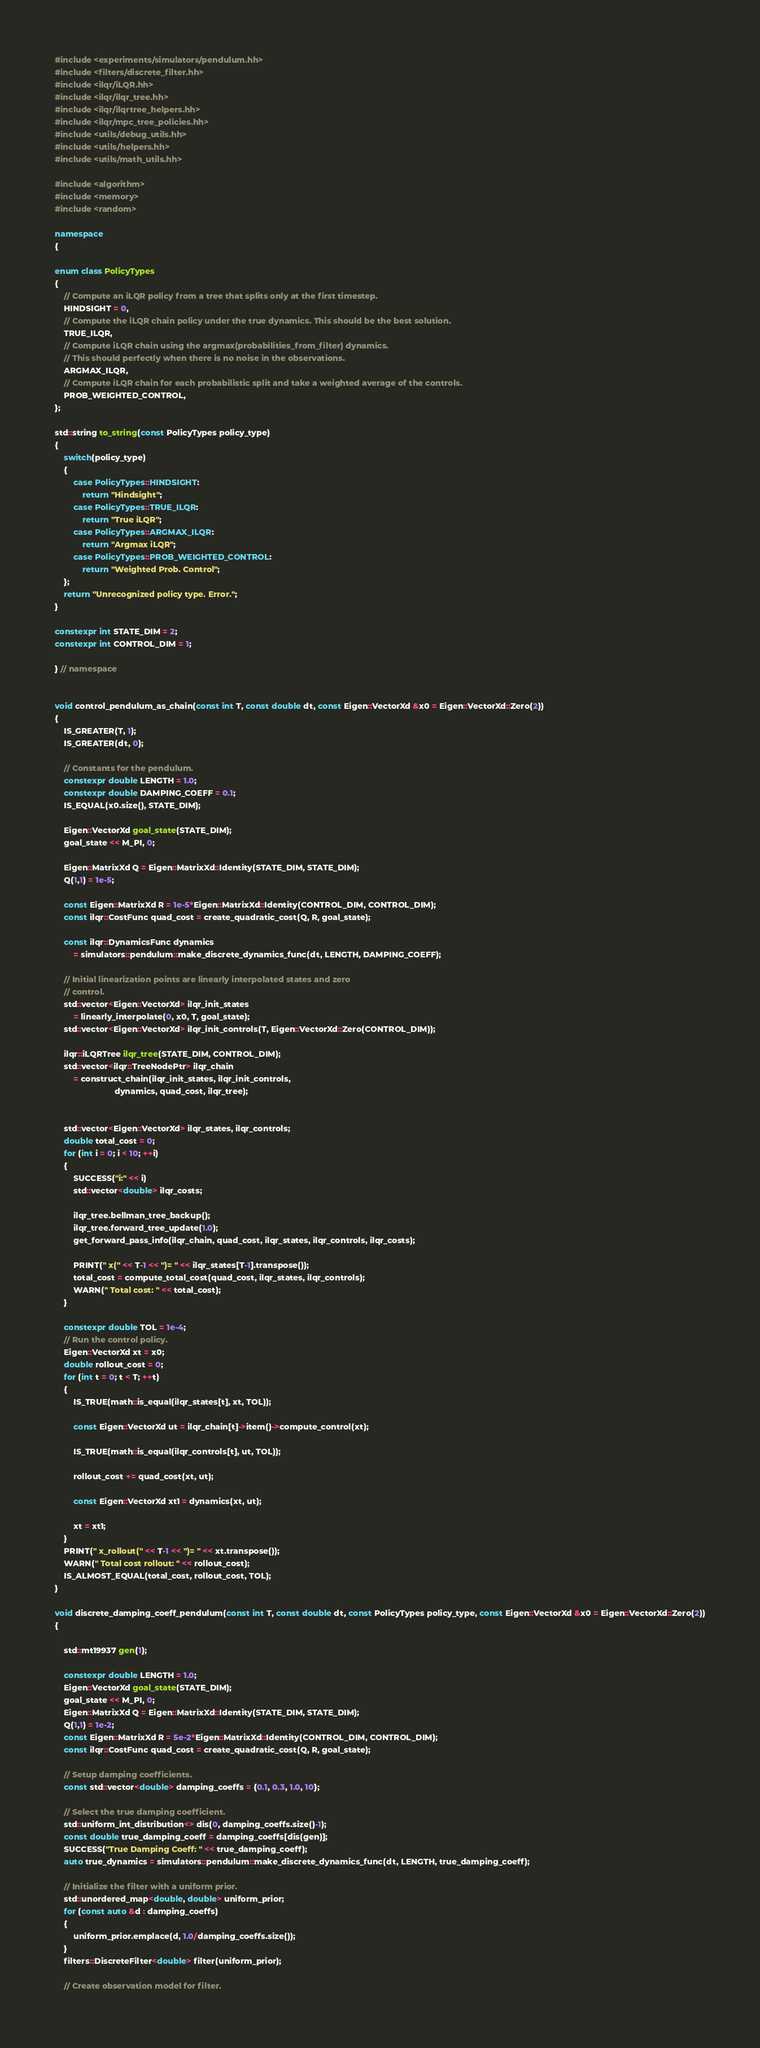Convert code to text. <code><loc_0><loc_0><loc_500><loc_500><_C++_>
#include <experiments/simulators/pendulum.hh>
#include <filters/discrete_filter.hh>
#include <ilqr/iLQR.hh>
#include <ilqr/ilqr_tree.hh>
#include <ilqr/ilqrtree_helpers.hh>
#include <ilqr/mpc_tree_policies.hh>
#include <utils/debug_utils.hh>
#include <utils/helpers.hh>
#include <utils/math_utils.hh>

#include <algorithm>
#include <memory>
#include <random>

namespace 
{

enum class PolicyTypes
{
    // Compute an iLQR policy from a tree that splits only at the first timestep.
    HINDSIGHT = 0,
    // Compute the iLQR chain policy under the true dynamics. This should be the best solution.
    TRUE_ILQR,
    // Compute iLQR chain using the argmax(probabilities_from_filter) dynamics.
    // This should perfectly when there is no noise in the observations.
    ARGMAX_ILQR,
    // Compute iLQR chain for each probabilistic split and take a weighted average of the controls.
    PROB_WEIGHTED_CONTROL,
};

std::string to_string(const PolicyTypes policy_type)
{
    switch(policy_type)
    {
        case PolicyTypes::HINDSIGHT:
            return "Hindsight";
        case PolicyTypes::TRUE_ILQR:
            return "True iLQR";
        case PolicyTypes::ARGMAX_ILQR:
            return "Argmax iLQR";
        case PolicyTypes::PROB_WEIGHTED_CONTROL:
            return "Weighted Prob. Control";
    };
    return "Unrecognized policy type. Error.";
}

constexpr int STATE_DIM = 2;
constexpr int CONTROL_DIM = 1;

} // namespace


void control_pendulum_as_chain(const int T, const double dt, const Eigen::VectorXd &x0 = Eigen::VectorXd::Zero(2))
{
    IS_GREATER(T, 1);
    IS_GREATER(dt, 0);

    // Constants for the pendulum.
    constexpr double LENGTH = 1.0;
    constexpr double DAMPING_COEFF = 0.1;
    IS_EQUAL(x0.size(), STATE_DIM);

    Eigen::VectorXd goal_state(STATE_DIM); 
    goal_state << M_PI, 0;

    Eigen::MatrixXd Q = Eigen::MatrixXd::Identity(STATE_DIM, STATE_DIM);
    Q(1,1) = 1e-5;

    const Eigen::MatrixXd R = 1e-5*Eigen::MatrixXd::Identity(CONTROL_DIM, CONTROL_DIM);
    const ilqr::CostFunc quad_cost = create_quadratic_cost(Q, R, goal_state);

    const ilqr::DynamicsFunc dynamics 
        = simulators::pendulum::make_discrete_dynamics_func(dt, LENGTH, DAMPING_COEFF);

    // Initial linearization points are linearly interpolated states and zero
    // control.
    std::vector<Eigen::VectorXd> ilqr_init_states 
        = linearly_interpolate(0, x0, T, goal_state);
    std::vector<Eigen::VectorXd> ilqr_init_controls(T, Eigen::VectorXd::Zero(CONTROL_DIM));

    ilqr::iLQRTree ilqr_tree(STATE_DIM, CONTROL_DIM);
    std::vector<ilqr::TreeNodePtr> ilqr_chain 
        = construct_chain(ilqr_init_states, ilqr_init_controls,
                          dynamics, quad_cost, ilqr_tree);


    std::vector<Eigen::VectorXd> ilqr_states, ilqr_controls;
    double total_cost = 0;
    for (int i = 0; i < 10; ++i)
    {
        SUCCESS("i:" << i)
        std::vector<double> ilqr_costs;

        ilqr_tree.bellman_tree_backup();
        ilqr_tree.forward_tree_update(1.0);
        get_forward_pass_info(ilqr_chain, quad_cost, ilqr_states, ilqr_controls, ilqr_costs);

        PRINT(" x(" << T-1 << ")= " << ilqr_states[T-1].transpose());
        total_cost = compute_total_cost(quad_cost, ilqr_states, ilqr_controls);
        WARN(" Total cost: " << total_cost);
    }

    constexpr double TOL = 1e-4;
    // Run the control policy.
    Eigen::VectorXd xt = x0;
    double rollout_cost = 0;
    for (int t = 0; t < T; ++t)
    {
        IS_TRUE(math::is_equal(ilqr_states[t], xt, TOL));

        const Eigen::VectorXd ut = ilqr_chain[t]->item()->compute_control(xt);

        IS_TRUE(math::is_equal(ilqr_controls[t], ut, TOL));

        rollout_cost += quad_cost(xt, ut);

        const Eigen::VectorXd xt1 = dynamics(xt, ut);

        xt = xt1;
    }
    PRINT(" x_rollout(" << T-1 << ")= " << xt.transpose());
    WARN(" Total cost rollout: " << rollout_cost);
    IS_ALMOST_EQUAL(total_cost, rollout_cost, TOL);
}

void discrete_damping_coeff_pendulum(const int T, const double dt, const PolicyTypes policy_type, const Eigen::VectorXd &x0 = Eigen::VectorXd::Zero(2))
{

    std::mt19937 gen(1);

    constexpr double LENGTH = 1.0;
    Eigen::VectorXd goal_state(STATE_DIM); 
    goal_state << M_PI, 0;
    Eigen::MatrixXd Q = Eigen::MatrixXd::Identity(STATE_DIM, STATE_DIM);
    Q(1,1) = 1e-2;
    const Eigen::MatrixXd R = 5e-2*Eigen::MatrixXd::Identity(CONTROL_DIM, CONTROL_DIM);
    const ilqr::CostFunc quad_cost = create_quadratic_cost(Q, R, goal_state);

    // Setup damping coefficients. 
    const std::vector<double> damping_coeffs = {0.1, 0.3, 1.0, 10};

    // Select the true damping coefficient.
    std::uniform_int_distribution<> dis(0, damping_coeffs.size()-1);
    const double true_damping_coeff = damping_coeffs[dis(gen)];
    SUCCESS("True Damping Coeff: " << true_damping_coeff);
    auto true_dynamics = simulators::pendulum::make_discrete_dynamics_func(dt, LENGTH, true_damping_coeff);

    // Initialize the filter with a uniform prior.
    std::unordered_map<double, double> uniform_prior;
    for (const auto &d : damping_coeffs)
    {
        uniform_prior.emplace(d, 1.0/damping_coeffs.size());
    }
    filters::DiscreteFilter<double> filter(uniform_prior);

    // Create observation model for filter.</code> 